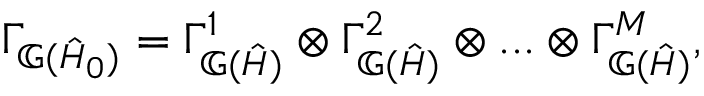<formula> <loc_0><loc_0><loc_500><loc_500>\Gamma _ { \mathbb { G } ( \hat { H } _ { 0 } ) } = \Gamma _ { \mathbb { G } ( \hat { H } ) } ^ { 1 } \otimes \Gamma _ { \mathbb { G } ( \hat { H } ) } ^ { 2 } \otimes \dots \otimes \Gamma _ { \mathbb { G } ( \hat { H } ) } ^ { M } ,</formula> 